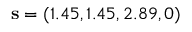<formula> <loc_0><loc_0><loc_500><loc_500>s = ( 1 . 4 5 , 1 . 4 5 , 2 . 8 9 , 0 )</formula> 